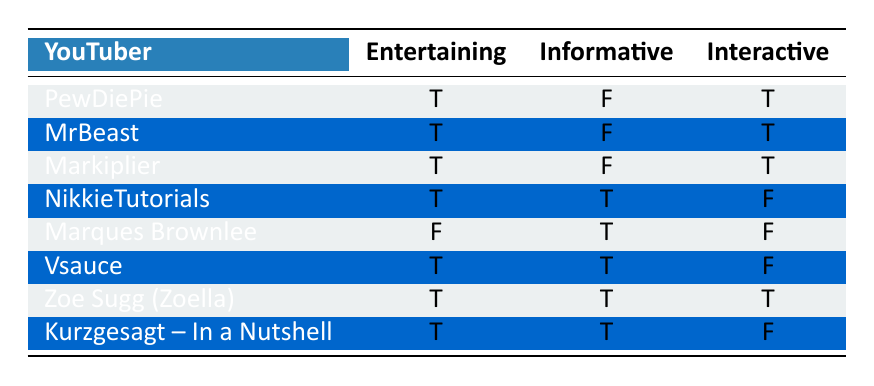What types of content does PewDiePie share? Referring to the table, PewDiePie shares "Let's Plays," "Vlogs," "Meme Reviews," and "Game Commentary."
Answer: Let's Plays, Vlogs, Meme Reviews, Game Commentary Which YouTuber is informative but not entertaining? By examining the table, the only YouTuber listed as informative (true) and not entertaining (false) is Marques Brownlee.
Answer: Marques Brownlee How many YouTubers create interactive content? The table shows that the YouTubers who are interactive (true) are PewDiePie, MrBeast, Markiplier, and Zoe Sugg (Zoella). That's a total of 4 YouTubers.
Answer: 4 Is NikkieTutorials considered interactive? According to the table, NikkieTutorials has an "Interactive" status of false, meaning she is not considered interactive.
Answer: No What is the total number of YouTubers who create entertaining content? Looking at the table, the YouTubers marked as entertaining (true) are PewDiePie, MrBeast, Markiplier, NikkieTutorials, Vsauce, Zoe Sugg (Zoella), and Kurzgesagt – In a Nutshell. This counts to 7 YouTubers in total.
Answer: 7 How many YouTubers produce content that is both entertaining and informative? From the table, the YouTubers marked both entertaining (true) and informative (true) are NikkieTutorials, Vsauce, and Zoe Sugg (Zoella). This gives a total of 3 such YouTubers.
Answer: 3 Which YouTuber is both entertaining and interactive, but not informative? The table shows that PewDiePie, MrBeast, and Markiplier are entertaining (true) and interactive (true), with a not informative status (false). Thus, these three fit the criteria.
Answer: PewDiePie, MrBeast, Markiplier How many YouTubers are neither entertaining nor interactive? By checking the interactive (false) and entertaining (false) status in the table, only Marques Brownlee fits this description, meaning there is just 1 YouTuber.
Answer: 1 